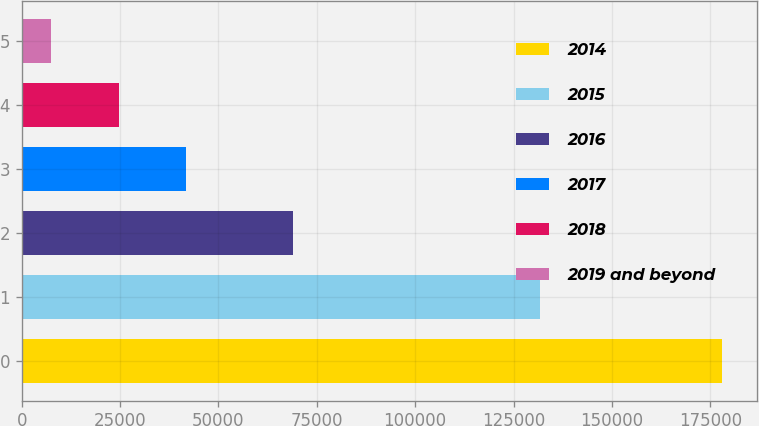Convert chart to OTSL. <chart><loc_0><loc_0><loc_500><loc_500><bar_chart><fcel>2014<fcel>2015<fcel>2016<fcel>2017<fcel>2018<fcel>2019 and beyond<nl><fcel>178068<fcel>131706<fcel>68933<fcel>41684<fcel>24636<fcel>7588<nl></chart> 